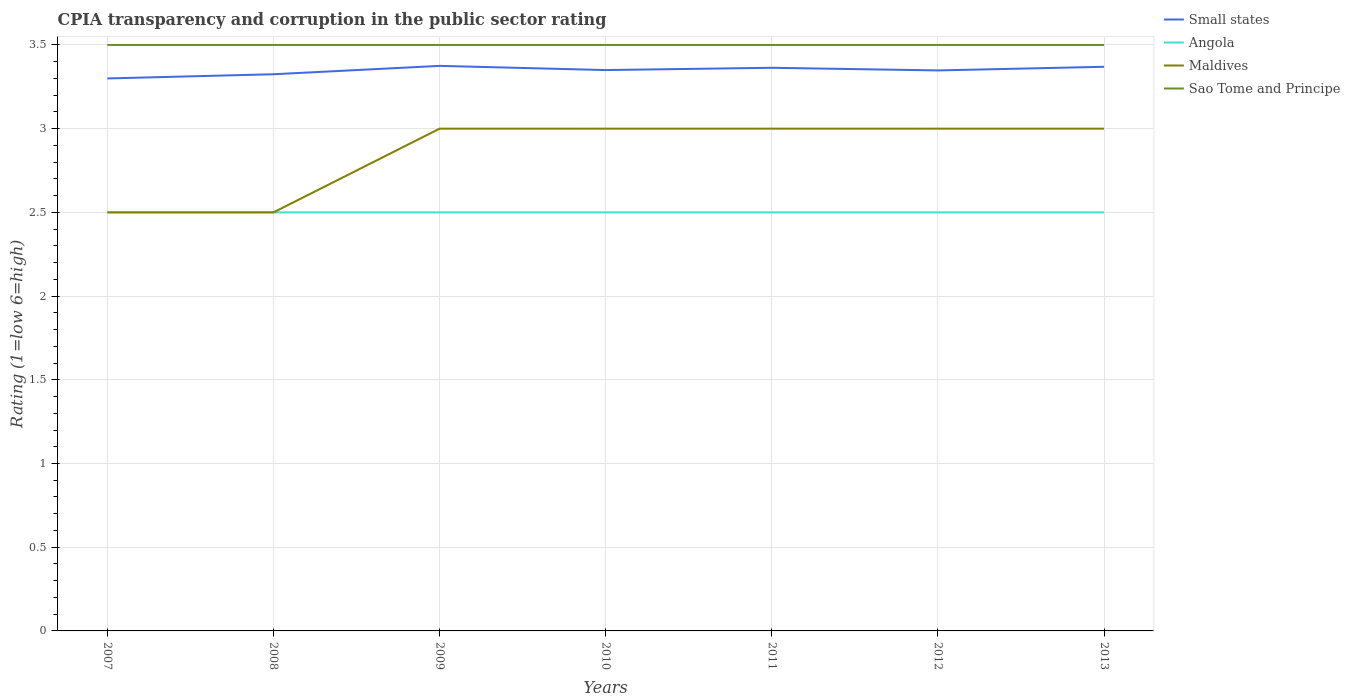How many different coloured lines are there?
Offer a terse response. 4. Does the line corresponding to Angola intersect with the line corresponding to Maldives?
Ensure brevity in your answer.  Yes. In which year was the CPIA rating in Sao Tome and Principe maximum?
Give a very brief answer. 2007. What is the total CPIA rating in Small states in the graph?
Your answer should be very brief. 0. Does the graph contain grids?
Give a very brief answer. Yes. How many legend labels are there?
Provide a succinct answer. 4. What is the title of the graph?
Your answer should be compact. CPIA transparency and corruption in the public sector rating. What is the Rating (1=low 6=high) of Small states in 2007?
Your answer should be very brief. 3.3. What is the Rating (1=low 6=high) in Small states in 2008?
Offer a terse response. 3.33. What is the Rating (1=low 6=high) of Angola in 2008?
Keep it short and to the point. 2.5. What is the Rating (1=low 6=high) of Maldives in 2008?
Your answer should be compact. 2.5. What is the Rating (1=low 6=high) in Sao Tome and Principe in 2008?
Your answer should be very brief. 3.5. What is the Rating (1=low 6=high) in Small states in 2009?
Your answer should be compact. 3.38. What is the Rating (1=low 6=high) of Angola in 2009?
Provide a succinct answer. 2.5. What is the Rating (1=low 6=high) of Small states in 2010?
Provide a short and direct response. 3.35. What is the Rating (1=low 6=high) in Small states in 2011?
Your response must be concise. 3.36. What is the Rating (1=low 6=high) in Angola in 2011?
Your answer should be compact. 2.5. What is the Rating (1=low 6=high) of Small states in 2012?
Give a very brief answer. 3.35. What is the Rating (1=low 6=high) in Maldives in 2012?
Your response must be concise. 3. What is the Rating (1=low 6=high) of Sao Tome and Principe in 2012?
Give a very brief answer. 3.5. What is the Rating (1=low 6=high) of Small states in 2013?
Your answer should be very brief. 3.37. Across all years, what is the maximum Rating (1=low 6=high) in Small states?
Provide a short and direct response. 3.38. Across all years, what is the maximum Rating (1=low 6=high) of Angola?
Provide a succinct answer. 2.5. Across all years, what is the maximum Rating (1=low 6=high) in Maldives?
Keep it short and to the point. 3. Across all years, what is the maximum Rating (1=low 6=high) in Sao Tome and Principe?
Offer a very short reply. 3.5. Across all years, what is the minimum Rating (1=low 6=high) in Small states?
Offer a very short reply. 3.3. Across all years, what is the minimum Rating (1=low 6=high) of Maldives?
Your response must be concise. 2.5. What is the total Rating (1=low 6=high) in Small states in the graph?
Provide a short and direct response. 23.43. What is the total Rating (1=low 6=high) in Angola in the graph?
Give a very brief answer. 17.5. What is the total Rating (1=low 6=high) of Maldives in the graph?
Your answer should be compact. 20. What is the difference between the Rating (1=low 6=high) of Small states in 2007 and that in 2008?
Ensure brevity in your answer.  -0.03. What is the difference between the Rating (1=low 6=high) in Maldives in 2007 and that in 2008?
Provide a short and direct response. 0. What is the difference between the Rating (1=low 6=high) of Small states in 2007 and that in 2009?
Offer a terse response. -0.07. What is the difference between the Rating (1=low 6=high) of Sao Tome and Principe in 2007 and that in 2009?
Ensure brevity in your answer.  0. What is the difference between the Rating (1=low 6=high) in Angola in 2007 and that in 2010?
Ensure brevity in your answer.  0. What is the difference between the Rating (1=low 6=high) in Maldives in 2007 and that in 2010?
Offer a terse response. -0.5. What is the difference between the Rating (1=low 6=high) in Sao Tome and Principe in 2007 and that in 2010?
Your answer should be compact. 0. What is the difference between the Rating (1=low 6=high) in Small states in 2007 and that in 2011?
Your answer should be compact. -0.06. What is the difference between the Rating (1=low 6=high) of Maldives in 2007 and that in 2011?
Your answer should be compact. -0.5. What is the difference between the Rating (1=low 6=high) of Sao Tome and Principe in 2007 and that in 2011?
Provide a short and direct response. 0. What is the difference between the Rating (1=low 6=high) in Small states in 2007 and that in 2012?
Offer a very short reply. -0.05. What is the difference between the Rating (1=low 6=high) of Angola in 2007 and that in 2012?
Offer a very short reply. 0. What is the difference between the Rating (1=low 6=high) of Maldives in 2007 and that in 2012?
Make the answer very short. -0.5. What is the difference between the Rating (1=low 6=high) of Sao Tome and Principe in 2007 and that in 2012?
Your answer should be very brief. 0. What is the difference between the Rating (1=low 6=high) of Small states in 2007 and that in 2013?
Offer a terse response. -0.07. What is the difference between the Rating (1=low 6=high) in Angola in 2007 and that in 2013?
Give a very brief answer. 0. What is the difference between the Rating (1=low 6=high) of Small states in 2008 and that in 2009?
Provide a short and direct response. -0.05. What is the difference between the Rating (1=low 6=high) of Angola in 2008 and that in 2009?
Your answer should be very brief. 0. What is the difference between the Rating (1=low 6=high) in Maldives in 2008 and that in 2009?
Make the answer very short. -0.5. What is the difference between the Rating (1=low 6=high) in Small states in 2008 and that in 2010?
Provide a succinct answer. -0.03. What is the difference between the Rating (1=low 6=high) in Angola in 2008 and that in 2010?
Give a very brief answer. 0. What is the difference between the Rating (1=low 6=high) of Small states in 2008 and that in 2011?
Your answer should be very brief. -0.04. What is the difference between the Rating (1=low 6=high) of Sao Tome and Principe in 2008 and that in 2011?
Offer a very short reply. 0. What is the difference between the Rating (1=low 6=high) in Small states in 2008 and that in 2012?
Make the answer very short. -0.02. What is the difference between the Rating (1=low 6=high) of Angola in 2008 and that in 2012?
Offer a very short reply. 0. What is the difference between the Rating (1=low 6=high) of Sao Tome and Principe in 2008 and that in 2012?
Provide a short and direct response. 0. What is the difference between the Rating (1=low 6=high) in Small states in 2008 and that in 2013?
Keep it short and to the point. -0.04. What is the difference between the Rating (1=low 6=high) of Angola in 2008 and that in 2013?
Your answer should be compact. 0. What is the difference between the Rating (1=low 6=high) in Sao Tome and Principe in 2008 and that in 2013?
Your answer should be compact. 0. What is the difference between the Rating (1=low 6=high) of Small states in 2009 and that in 2010?
Your answer should be very brief. 0.03. What is the difference between the Rating (1=low 6=high) of Angola in 2009 and that in 2010?
Provide a succinct answer. 0. What is the difference between the Rating (1=low 6=high) in Sao Tome and Principe in 2009 and that in 2010?
Provide a short and direct response. 0. What is the difference between the Rating (1=low 6=high) of Small states in 2009 and that in 2011?
Make the answer very short. 0.01. What is the difference between the Rating (1=low 6=high) of Angola in 2009 and that in 2011?
Offer a very short reply. 0. What is the difference between the Rating (1=low 6=high) in Maldives in 2009 and that in 2011?
Your answer should be compact. 0. What is the difference between the Rating (1=low 6=high) in Small states in 2009 and that in 2012?
Provide a short and direct response. 0.03. What is the difference between the Rating (1=low 6=high) in Angola in 2009 and that in 2012?
Your answer should be very brief. 0. What is the difference between the Rating (1=low 6=high) of Maldives in 2009 and that in 2012?
Make the answer very short. 0. What is the difference between the Rating (1=low 6=high) in Sao Tome and Principe in 2009 and that in 2012?
Provide a short and direct response. 0. What is the difference between the Rating (1=low 6=high) in Small states in 2009 and that in 2013?
Ensure brevity in your answer.  0.01. What is the difference between the Rating (1=low 6=high) in Angola in 2009 and that in 2013?
Your response must be concise. 0. What is the difference between the Rating (1=low 6=high) of Sao Tome and Principe in 2009 and that in 2013?
Your answer should be compact. 0. What is the difference between the Rating (1=low 6=high) in Small states in 2010 and that in 2011?
Offer a very short reply. -0.01. What is the difference between the Rating (1=low 6=high) in Small states in 2010 and that in 2012?
Keep it short and to the point. 0. What is the difference between the Rating (1=low 6=high) in Angola in 2010 and that in 2012?
Your answer should be very brief. 0. What is the difference between the Rating (1=low 6=high) in Maldives in 2010 and that in 2012?
Provide a succinct answer. 0. What is the difference between the Rating (1=low 6=high) in Small states in 2010 and that in 2013?
Offer a terse response. -0.02. What is the difference between the Rating (1=low 6=high) of Small states in 2011 and that in 2012?
Ensure brevity in your answer.  0.02. What is the difference between the Rating (1=low 6=high) of Small states in 2011 and that in 2013?
Make the answer very short. -0.01. What is the difference between the Rating (1=low 6=high) of Angola in 2011 and that in 2013?
Offer a terse response. 0. What is the difference between the Rating (1=low 6=high) of Maldives in 2011 and that in 2013?
Your answer should be compact. 0. What is the difference between the Rating (1=low 6=high) in Small states in 2012 and that in 2013?
Make the answer very short. -0.02. What is the difference between the Rating (1=low 6=high) in Angola in 2012 and that in 2013?
Offer a very short reply. 0. What is the difference between the Rating (1=low 6=high) of Maldives in 2012 and that in 2013?
Your response must be concise. 0. What is the difference between the Rating (1=low 6=high) in Sao Tome and Principe in 2012 and that in 2013?
Provide a succinct answer. 0. What is the difference between the Rating (1=low 6=high) of Small states in 2007 and the Rating (1=low 6=high) of Sao Tome and Principe in 2008?
Offer a terse response. -0.2. What is the difference between the Rating (1=low 6=high) in Angola in 2007 and the Rating (1=low 6=high) in Sao Tome and Principe in 2008?
Provide a succinct answer. -1. What is the difference between the Rating (1=low 6=high) in Small states in 2007 and the Rating (1=low 6=high) in Angola in 2009?
Ensure brevity in your answer.  0.8. What is the difference between the Rating (1=low 6=high) of Angola in 2007 and the Rating (1=low 6=high) of Maldives in 2009?
Provide a succinct answer. -0.5. What is the difference between the Rating (1=low 6=high) of Small states in 2007 and the Rating (1=low 6=high) of Angola in 2010?
Your answer should be very brief. 0.8. What is the difference between the Rating (1=low 6=high) of Small states in 2007 and the Rating (1=low 6=high) of Maldives in 2010?
Provide a short and direct response. 0.3. What is the difference between the Rating (1=low 6=high) of Small states in 2007 and the Rating (1=low 6=high) of Sao Tome and Principe in 2010?
Provide a succinct answer. -0.2. What is the difference between the Rating (1=low 6=high) of Angola in 2007 and the Rating (1=low 6=high) of Sao Tome and Principe in 2010?
Provide a succinct answer. -1. What is the difference between the Rating (1=low 6=high) in Small states in 2007 and the Rating (1=low 6=high) in Maldives in 2011?
Your answer should be compact. 0.3. What is the difference between the Rating (1=low 6=high) of Angola in 2007 and the Rating (1=low 6=high) of Maldives in 2011?
Your answer should be very brief. -0.5. What is the difference between the Rating (1=low 6=high) in Angola in 2007 and the Rating (1=low 6=high) in Sao Tome and Principe in 2011?
Make the answer very short. -1. What is the difference between the Rating (1=low 6=high) in Maldives in 2007 and the Rating (1=low 6=high) in Sao Tome and Principe in 2011?
Make the answer very short. -1. What is the difference between the Rating (1=low 6=high) of Small states in 2007 and the Rating (1=low 6=high) of Angola in 2012?
Provide a short and direct response. 0.8. What is the difference between the Rating (1=low 6=high) in Small states in 2007 and the Rating (1=low 6=high) in Angola in 2013?
Give a very brief answer. 0.8. What is the difference between the Rating (1=low 6=high) of Small states in 2007 and the Rating (1=low 6=high) of Maldives in 2013?
Provide a short and direct response. 0.3. What is the difference between the Rating (1=low 6=high) in Small states in 2007 and the Rating (1=low 6=high) in Sao Tome and Principe in 2013?
Provide a succinct answer. -0.2. What is the difference between the Rating (1=low 6=high) of Angola in 2007 and the Rating (1=low 6=high) of Maldives in 2013?
Provide a succinct answer. -0.5. What is the difference between the Rating (1=low 6=high) in Small states in 2008 and the Rating (1=low 6=high) in Angola in 2009?
Offer a terse response. 0.82. What is the difference between the Rating (1=low 6=high) of Small states in 2008 and the Rating (1=low 6=high) of Maldives in 2009?
Provide a short and direct response. 0.33. What is the difference between the Rating (1=low 6=high) of Small states in 2008 and the Rating (1=low 6=high) of Sao Tome and Principe in 2009?
Make the answer very short. -0.17. What is the difference between the Rating (1=low 6=high) of Angola in 2008 and the Rating (1=low 6=high) of Sao Tome and Principe in 2009?
Ensure brevity in your answer.  -1. What is the difference between the Rating (1=low 6=high) in Small states in 2008 and the Rating (1=low 6=high) in Angola in 2010?
Give a very brief answer. 0.82. What is the difference between the Rating (1=low 6=high) in Small states in 2008 and the Rating (1=low 6=high) in Maldives in 2010?
Your answer should be very brief. 0.33. What is the difference between the Rating (1=low 6=high) in Small states in 2008 and the Rating (1=low 6=high) in Sao Tome and Principe in 2010?
Provide a short and direct response. -0.17. What is the difference between the Rating (1=low 6=high) in Maldives in 2008 and the Rating (1=low 6=high) in Sao Tome and Principe in 2010?
Your response must be concise. -1. What is the difference between the Rating (1=low 6=high) in Small states in 2008 and the Rating (1=low 6=high) in Angola in 2011?
Offer a terse response. 0.82. What is the difference between the Rating (1=low 6=high) of Small states in 2008 and the Rating (1=low 6=high) of Maldives in 2011?
Your answer should be compact. 0.33. What is the difference between the Rating (1=low 6=high) in Small states in 2008 and the Rating (1=low 6=high) in Sao Tome and Principe in 2011?
Give a very brief answer. -0.17. What is the difference between the Rating (1=low 6=high) in Small states in 2008 and the Rating (1=low 6=high) in Angola in 2012?
Your answer should be very brief. 0.82. What is the difference between the Rating (1=low 6=high) in Small states in 2008 and the Rating (1=low 6=high) in Maldives in 2012?
Offer a terse response. 0.33. What is the difference between the Rating (1=low 6=high) of Small states in 2008 and the Rating (1=low 6=high) of Sao Tome and Principe in 2012?
Ensure brevity in your answer.  -0.17. What is the difference between the Rating (1=low 6=high) in Angola in 2008 and the Rating (1=low 6=high) in Sao Tome and Principe in 2012?
Your answer should be very brief. -1. What is the difference between the Rating (1=low 6=high) in Small states in 2008 and the Rating (1=low 6=high) in Angola in 2013?
Your answer should be compact. 0.82. What is the difference between the Rating (1=low 6=high) in Small states in 2008 and the Rating (1=low 6=high) in Maldives in 2013?
Ensure brevity in your answer.  0.33. What is the difference between the Rating (1=low 6=high) of Small states in 2008 and the Rating (1=low 6=high) of Sao Tome and Principe in 2013?
Your answer should be very brief. -0.17. What is the difference between the Rating (1=low 6=high) of Small states in 2009 and the Rating (1=low 6=high) of Sao Tome and Principe in 2010?
Keep it short and to the point. -0.12. What is the difference between the Rating (1=low 6=high) of Angola in 2009 and the Rating (1=low 6=high) of Maldives in 2010?
Give a very brief answer. -0.5. What is the difference between the Rating (1=low 6=high) of Angola in 2009 and the Rating (1=low 6=high) of Sao Tome and Principe in 2010?
Your response must be concise. -1. What is the difference between the Rating (1=low 6=high) of Maldives in 2009 and the Rating (1=low 6=high) of Sao Tome and Principe in 2010?
Your answer should be very brief. -0.5. What is the difference between the Rating (1=low 6=high) of Small states in 2009 and the Rating (1=low 6=high) of Angola in 2011?
Ensure brevity in your answer.  0.88. What is the difference between the Rating (1=low 6=high) in Small states in 2009 and the Rating (1=low 6=high) in Sao Tome and Principe in 2011?
Your response must be concise. -0.12. What is the difference between the Rating (1=low 6=high) in Angola in 2009 and the Rating (1=low 6=high) in Maldives in 2011?
Keep it short and to the point. -0.5. What is the difference between the Rating (1=low 6=high) in Angola in 2009 and the Rating (1=low 6=high) in Sao Tome and Principe in 2011?
Keep it short and to the point. -1. What is the difference between the Rating (1=low 6=high) of Small states in 2009 and the Rating (1=low 6=high) of Angola in 2012?
Your answer should be very brief. 0.88. What is the difference between the Rating (1=low 6=high) of Small states in 2009 and the Rating (1=low 6=high) of Sao Tome and Principe in 2012?
Your response must be concise. -0.12. What is the difference between the Rating (1=low 6=high) in Angola in 2009 and the Rating (1=low 6=high) in Maldives in 2012?
Provide a succinct answer. -0.5. What is the difference between the Rating (1=low 6=high) in Angola in 2009 and the Rating (1=low 6=high) in Sao Tome and Principe in 2012?
Provide a succinct answer. -1. What is the difference between the Rating (1=low 6=high) of Maldives in 2009 and the Rating (1=low 6=high) of Sao Tome and Principe in 2012?
Make the answer very short. -0.5. What is the difference between the Rating (1=low 6=high) in Small states in 2009 and the Rating (1=low 6=high) in Angola in 2013?
Give a very brief answer. 0.88. What is the difference between the Rating (1=low 6=high) in Small states in 2009 and the Rating (1=low 6=high) in Maldives in 2013?
Give a very brief answer. 0.38. What is the difference between the Rating (1=low 6=high) in Small states in 2009 and the Rating (1=low 6=high) in Sao Tome and Principe in 2013?
Make the answer very short. -0.12. What is the difference between the Rating (1=low 6=high) of Angola in 2009 and the Rating (1=low 6=high) of Sao Tome and Principe in 2013?
Your answer should be very brief. -1. What is the difference between the Rating (1=low 6=high) of Small states in 2010 and the Rating (1=low 6=high) of Angola in 2011?
Your response must be concise. 0.85. What is the difference between the Rating (1=low 6=high) of Small states in 2010 and the Rating (1=low 6=high) of Angola in 2012?
Offer a terse response. 0.85. What is the difference between the Rating (1=low 6=high) in Small states in 2010 and the Rating (1=low 6=high) in Maldives in 2012?
Provide a short and direct response. 0.35. What is the difference between the Rating (1=low 6=high) of Angola in 2010 and the Rating (1=low 6=high) of Sao Tome and Principe in 2012?
Ensure brevity in your answer.  -1. What is the difference between the Rating (1=low 6=high) of Small states in 2010 and the Rating (1=low 6=high) of Angola in 2013?
Ensure brevity in your answer.  0.85. What is the difference between the Rating (1=low 6=high) of Small states in 2010 and the Rating (1=low 6=high) of Maldives in 2013?
Offer a terse response. 0.35. What is the difference between the Rating (1=low 6=high) of Small states in 2010 and the Rating (1=low 6=high) of Sao Tome and Principe in 2013?
Your answer should be very brief. -0.15. What is the difference between the Rating (1=low 6=high) of Angola in 2010 and the Rating (1=low 6=high) of Sao Tome and Principe in 2013?
Provide a short and direct response. -1. What is the difference between the Rating (1=low 6=high) in Small states in 2011 and the Rating (1=low 6=high) in Angola in 2012?
Provide a succinct answer. 0.86. What is the difference between the Rating (1=low 6=high) of Small states in 2011 and the Rating (1=low 6=high) of Maldives in 2012?
Provide a short and direct response. 0.36. What is the difference between the Rating (1=low 6=high) in Small states in 2011 and the Rating (1=low 6=high) in Sao Tome and Principe in 2012?
Offer a very short reply. -0.14. What is the difference between the Rating (1=low 6=high) in Angola in 2011 and the Rating (1=low 6=high) in Sao Tome and Principe in 2012?
Provide a succinct answer. -1. What is the difference between the Rating (1=low 6=high) in Maldives in 2011 and the Rating (1=low 6=high) in Sao Tome and Principe in 2012?
Your answer should be compact. -0.5. What is the difference between the Rating (1=low 6=high) of Small states in 2011 and the Rating (1=low 6=high) of Angola in 2013?
Offer a very short reply. 0.86. What is the difference between the Rating (1=low 6=high) of Small states in 2011 and the Rating (1=low 6=high) of Maldives in 2013?
Offer a terse response. 0.36. What is the difference between the Rating (1=low 6=high) of Small states in 2011 and the Rating (1=low 6=high) of Sao Tome and Principe in 2013?
Provide a succinct answer. -0.14. What is the difference between the Rating (1=low 6=high) in Angola in 2011 and the Rating (1=low 6=high) in Maldives in 2013?
Your answer should be very brief. -0.5. What is the difference between the Rating (1=low 6=high) of Small states in 2012 and the Rating (1=low 6=high) of Angola in 2013?
Make the answer very short. 0.85. What is the difference between the Rating (1=low 6=high) of Small states in 2012 and the Rating (1=low 6=high) of Maldives in 2013?
Your answer should be compact. 0.35. What is the difference between the Rating (1=low 6=high) of Small states in 2012 and the Rating (1=low 6=high) of Sao Tome and Principe in 2013?
Your response must be concise. -0.15. What is the difference between the Rating (1=low 6=high) of Angola in 2012 and the Rating (1=low 6=high) of Maldives in 2013?
Offer a terse response. -0.5. What is the difference between the Rating (1=low 6=high) in Angola in 2012 and the Rating (1=low 6=high) in Sao Tome and Principe in 2013?
Give a very brief answer. -1. What is the difference between the Rating (1=low 6=high) of Maldives in 2012 and the Rating (1=low 6=high) of Sao Tome and Principe in 2013?
Offer a terse response. -0.5. What is the average Rating (1=low 6=high) in Small states per year?
Make the answer very short. 3.35. What is the average Rating (1=low 6=high) of Maldives per year?
Your response must be concise. 2.86. What is the average Rating (1=low 6=high) of Sao Tome and Principe per year?
Make the answer very short. 3.5. In the year 2007, what is the difference between the Rating (1=low 6=high) in Small states and Rating (1=low 6=high) in Angola?
Keep it short and to the point. 0.8. In the year 2007, what is the difference between the Rating (1=low 6=high) of Small states and Rating (1=low 6=high) of Sao Tome and Principe?
Your response must be concise. -0.2. In the year 2007, what is the difference between the Rating (1=low 6=high) in Angola and Rating (1=low 6=high) in Maldives?
Your answer should be compact. 0. In the year 2007, what is the difference between the Rating (1=low 6=high) in Angola and Rating (1=low 6=high) in Sao Tome and Principe?
Keep it short and to the point. -1. In the year 2008, what is the difference between the Rating (1=low 6=high) of Small states and Rating (1=low 6=high) of Angola?
Ensure brevity in your answer.  0.82. In the year 2008, what is the difference between the Rating (1=low 6=high) in Small states and Rating (1=low 6=high) in Maldives?
Provide a succinct answer. 0.82. In the year 2008, what is the difference between the Rating (1=low 6=high) of Small states and Rating (1=low 6=high) of Sao Tome and Principe?
Offer a very short reply. -0.17. In the year 2008, what is the difference between the Rating (1=low 6=high) of Angola and Rating (1=low 6=high) of Maldives?
Your answer should be very brief. 0. In the year 2009, what is the difference between the Rating (1=low 6=high) of Small states and Rating (1=low 6=high) of Maldives?
Ensure brevity in your answer.  0.38. In the year 2009, what is the difference between the Rating (1=low 6=high) in Small states and Rating (1=low 6=high) in Sao Tome and Principe?
Ensure brevity in your answer.  -0.12. In the year 2009, what is the difference between the Rating (1=low 6=high) of Maldives and Rating (1=low 6=high) of Sao Tome and Principe?
Provide a succinct answer. -0.5. In the year 2010, what is the difference between the Rating (1=low 6=high) in Small states and Rating (1=low 6=high) in Angola?
Give a very brief answer. 0.85. In the year 2010, what is the difference between the Rating (1=low 6=high) in Small states and Rating (1=low 6=high) in Sao Tome and Principe?
Ensure brevity in your answer.  -0.15. In the year 2010, what is the difference between the Rating (1=low 6=high) of Angola and Rating (1=low 6=high) of Sao Tome and Principe?
Your answer should be compact. -1. In the year 2011, what is the difference between the Rating (1=low 6=high) in Small states and Rating (1=low 6=high) in Angola?
Provide a succinct answer. 0.86. In the year 2011, what is the difference between the Rating (1=low 6=high) of Small states and Rating (1=low 6=high) of Maldives?
Provide a succinct answer. 0.36. In the year 2011, what is the difference between the Rating (1=low 6=high) of Small states and Rating (1=low 6=high) of Sao Tome and Principe?
Your response must be concise. -0.14. In the year 2011, what is the difference between the Rating (1=low 6=high) in Maldives and Rating (1=low 6=high) in Sao Tome and Principe?
Offer a terse response. -0.5. In the year 2012, what is the difference between the Rating (1=low 6=high) of Small states and Rating (1=low 6=high) of Angola?
Offer a terse response. 0.85. In the year 2012, what is the difference between the Rating (1=low 6=high) of Small states and Rating (1=low 6=high) of Maldives?
Ensure brevity in your answer.  0.35. In the year 2012, what is the difference between the Rating (1=low 6=high) of Small states and Rating (1=low 6=high) of Sao Tome and Principe?
Your response must be concise. -0.15. In the year 2012, what is the difference between the Rating (1=low 6=high) in Angola and Rating (1=low 6=high) in Maldives?
Ensure brevity in your answer.  -0.5. In the year 2012, what is the difference between the Rating (1=low 6=high) of Angola and Rating (1=low 6=high) of Sao Tome and Principe?
Your answer should be compact. -1. In the year 2012, what is the difference between the Rating (1=low 6=high) of Maldives and Rating (1=low 6=high) of Sao Tome and Principe?
Offer a terse response. -0.5. In the year 2013, what is the difference between the Rating (1=low 6=high) in Small states and Rating (1=low 6=high) in Angola?
Make the answer very short. 0.87. In the year 2013, what is the difference between the Rating (1=low 6=high) in Small states and Rating (1=low 6=high) in Maldives?
Offer a very short reply. 0.37. In the year 2013, what is the difference between the Rating (1=low 6=high) in Small states and Rating (1=low 6=high) in Sao Tome and Principe?
Your answer should be very brief. -0.13. In the year 2013, what is the difference between the Rating (1=low 6=high) in Maldives and Rating (1=low 6=high) in Sao Tome and Principe?
Ensure brevity in your answer.  -0.5. What is the ratio of the Rating (1=low 6=high) of Angola in 2007 to that in 2008?
Offer a terse response. 1. What is the ratio of the Rating (1=low 6=high) in Maldives in 2007 to that in 2008?
Your answer should be very brief. 1. What is the ratio of the Rating (1=low 6=high) in Small states in 2007 to that in 2009?
Your answer should be very brief. 0.98. What is the ratio of the Rating (1=low 6=high) of Small states in 2007 to that in 2010?
Your response must be concise. 0.99. What is the ratio of the Rating (1=low 6=high) in Sao Tome and Principe in 2007 to that in 2010?
Provide a short and direct response. 1. What is the ratio of the Rating (1=low 6=high) of Small states in 2007 to that in 2011?
Keep it short and to the point. 0.98. What is the ratio of the Rating (1=low 6=high) in Angola in 2007 to that in 2011?
Keep it short and to the point. 1. What is the ratio of the Rating (1=low 6=high) of Sao Tome and Principe in 2007 to that in 2011?
Your answer should be compact. 1. What is the ratio of the Rating (1=low 6=high) in Small states in 2007 to that in 2012?
Keep it short and to the point. 0.99. What is the ratio of the Rating (1=low 6=high) of Angola in 2007 to that in 2012?
Your response must be concise. 1. What is the ratio of the Rating (1=low 6=high) of Sao Tome and Principe in 2007 to that in 2012?
Offer a terse response. 1. What is the ratio of the Rating (1=low 6=high) of Small states in 2007 to that in 2013?
Give a very brief answer. 0.98. What is the ratio of the Rating (1=low 6=high) of Angola in 2007 to that in 2013?
Make the answer very short. 1. What is the ratio of the Rating (1=low 6=high) of Sao Tome and Principe in 2007 to that in 2013?
Offer a very short reply. 1. What is the ratio of the Rating (1=low 6=high) in Small states in 2008 to that in 2009?
Make the answer very short. 0.99. What is the ratio of the Rating (1=low 6=high) of Maldives in 2008 to that in 2009?
Your answer should be very brief. 0.83. What is the ratio of the Rating (1=low 6=high) of Sao Tome and Principe in 2008 to that in 2009?
Your response must be concise. 1. What is the ratio of the Rating (1=low 6=high) in Angola in 2008 to that in 2010?
Ensure brevity in your answer.  1. What is the ratio of the Rating (1=low 6=high) in Maldives in 2008 to that in 2010?
Offer a terse response. 0.83. What is the ratio of the Rating (1=low 6=high) of Small states in 2008 to that in 2011?
Make the answer very short. 0.99. What is the ratio of the Rating (1=low 6=high) in Angola in 2008 to that in 2011?
Offer a terse response. 1. What is the ratio of the Rating (1=low 6=high) of Maldives in 2008 to that in 2011?
Ensure brevity in your answer.  0.83. What is the ratio of the Rating (1=low 6=high) in Sao Tome and Principe in 2008 to that in 2011?
Your answer should be compact. 1. What is the ratio of the Rating (1=low 6=high) of Small states in 2008 to that in 2012?
Ensure brevity in your answer.  0.99. What is the ratio of the Rating (1=low 6=high) of Angola in 2008 to that in 2012?
Offer a very short reply. 1. What is the ratio of the Rating (1=low 6=high) of Sao Tome and Principe in 2008 to that in 2012?
Offer a terse response. 1. What is the ratio of the Rating (1=low 6=high) of Small states in 2008 to that in 2013?
Your answer should be compact. 0.99. What is the ratio of the Rating (1=low 6=high) in Maldives in 2008 to that in 2013?
Your response must be concise. 0.83. What is the ratio of the Rating (1=low 6=high) of Sao Tome and Principe in 2008 to that in 2013?
Your response must be concise. 1. What is the ratio of the Rating (1=low 6=high) in Small states in 2009 to that in 2010?
Your answer should be compact. 1.01. What is the ratio of the Rating (1=low 6=high) of Maldives in 2009 to that in 2010?
Your response must be concise. 1. What is the ratio of the Rating (1=low 6=high) of Maldives in 2009 to that in 2011?
Your response must be concise. 1. What is the ratio of the Rating (1=low 6=high) in Small states in 2009 to that in 2012?
Offer a terse response. 1.01. What is the ratio of the Rating (1=low 6=high) in Maldives in 2009 to that in 2012?
Your response must be concise. 1. What is the ratio of the Rating (1=low 6=high) of Sao Tome and Principe in 2009 to that in 2012?
Ensure brevity in your answer.  1. What is the ratio of the Rating (1=low 6=high) of Angola in 2009 to that in 2013?
Offer a very short reply. 1. What is the ratio of the Rating (1=low 6=high) in Sao Tome and Principe in 2010 to that in 2011?
Your response must be concise. 1. What is the ratio of the Rating (1=low 6=high) in Maldives in 2010 to that in 2012?
Make the answer very short. 1. What is the ratio of the Rating (1=low 6=high) of Sao Tome and Principe in 2010 to that in 2012?
Your response must be concise. 1. What is the ratio of the Rating (1=low 6=high) of Sao Tome and Principe in 2010 to that in 2013?
Your response must be concise. 1. What is the ratio of the Rating (1=low 6=high) of Small states in 2011 to that in 2012?
Your answer should be very brief. 1. What is the ratio of the Rating (1=low 6=high) in Angola in 2011 to that in 2012?
Offer a very short reply. 1. What is the ratio of the Rating (1=low 6=high) in Small states in 2012 to that in 2013?
Keep it short and to the point. 0.99. What is the ratio of the Rating (1=low 6=high) of Sao Tome and Principe in 2012 to that in 2013?
Provide a short and direct response. 1. What is the difference between the highest and the second highest Rating (1=low 6=high) of Small states?
Offer a very short reply. 0.01. What is the difference between the highest and the second highest Rating (1=low 6=high) of Angola?
Provide a succinct answer. 0. What is the difference between the highest and the lowest Rating (1=low 6=high) of Small states?
Your response must be concise. 0.07. What is the difference between the highest and the lowest Rating (1=low 6=high) in Angola?
Offer a very short reply. 0. 